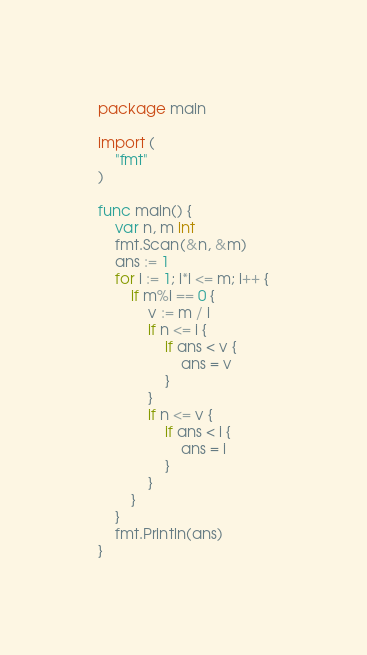<code> <loc_0><loc_0><loc_500><loc_500><_Go_>package main

import (
	"fmt"
)

func main() {
	var n, m int
	fmt.Scan(&n, &m)
	ans := 1
	for i := 1; i*i <= m; i++ {
		if m%i == 0 {
			v := m / i
			if n <= i {
				if ans < v {
					ans = v
				}
			}
			if n <= v {
				if ans < i {
					ans = i
				}
			}
		}
	}
	fmt.Println(ans)
}
</code> 